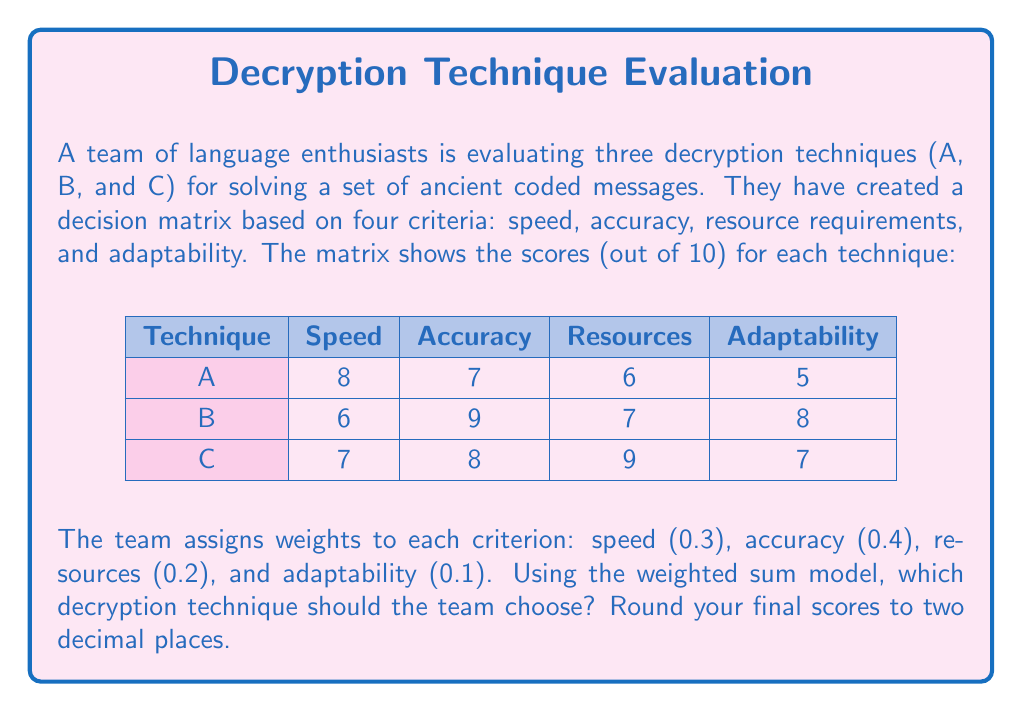Teach me how to tackle this problem. To solve this problem, we'll use the weighted sum model, which involves the following steps:

1) Multiply each score by its corresponding weight.
2) Sum these weighted scores for each technique.
3) Choose the technique with the highest total weighted score.

Let's calculate for each technique:

Technique A:
$$(8 \times 0.3) + (7 \times 0.4) + (6 \times 0.2) + (5 \times 0.1) = 2.4 + 2.8 + 1.2 + 0.5 = 6.90$$

Technique B:
$$(6 \times 0.3) + (9 \times 0.4) + (7 \times 0.2) + (8 \times 0.1) = 1.8 + 3.6 + 1.4 + 0.8 = 7.60$$

Technique C:
$$(7 \times 0.3) + (8 \times 0.4) + (9 \times 0.2) + (7 \times 0.1) = 2.1 + 3.2 + 1.8 + 0.7 = 7.80$$

Comparing the final scores:
A: 6.90
B: 7.60
C: 7.80

Technique C has the highest score, so it should be chosen.
Answer: Technique C (7.80) 